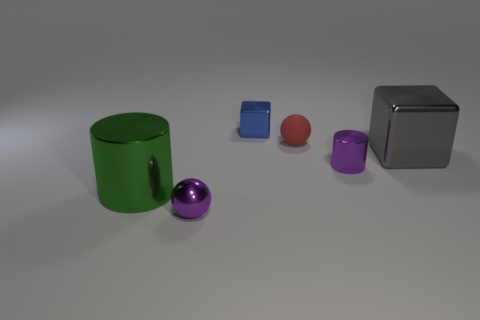Is there anything else that has the same size as the green metal cylinder?
Provide a succinct answer. Yes. Are there more large shiny cubes in front of the small purple metallic sphere than blue shiny objects right of the purple cylinder?
Your answer should be compact. No. The ball that is in front of the tiny purple object behind the sphere that is in front of the small red matte object is what color?
Provide a short and direct response. Purple. There is a cylinder that is right of the blue metallic block; is its color the same as the rubber sphere?
Ensure brevity in your answer.  No. How many other things are the same color as the matte object?
Your answer should be compact. 0. How many things are big yellow balls or big green cylinders?
Your response must be concise. 1. How many things are large gray rubber things or balls that are in front of the red matte thing?
Keep it short and to the point. 1. Does the large block have the same material as the big green thing?
Ensure brevity in your answer.  Yes. What number of other objects are the same material as the gray thing?
Offer a very short reply. 4. Are there more big red cubes than tiny rubber things?
Ensure brevity in your answer.  No. 